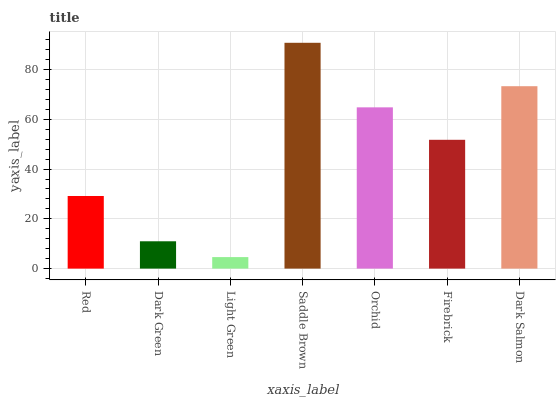Is Light Green the minimum?
Answer yes or no. Yes. Is Saddle Brown the maximum?
Answer yes or no. Yes. Is Dark Green the minimum?
Answer yes or no. No. Is Dark Green the maximum?
Answer yes or no. No. Is Red greater than Dark Green?
Answer yes or no. Yes. Is Dark Green less than Red?
Answer yes or no. Yes. Is Dark Green greater than Red?
Answer yes or no. No. Is Red less than Dark Green?
Answer yes or no. No. Is Firebrick the high median?
Answer yes or no. Yes. Is Firebrick the low median?
Answer yes or no. Yes. Is Dark Salmon the high median?
Answer yes or no. No. Is Dark Salmon the low median?
Answer yes or no. No. 